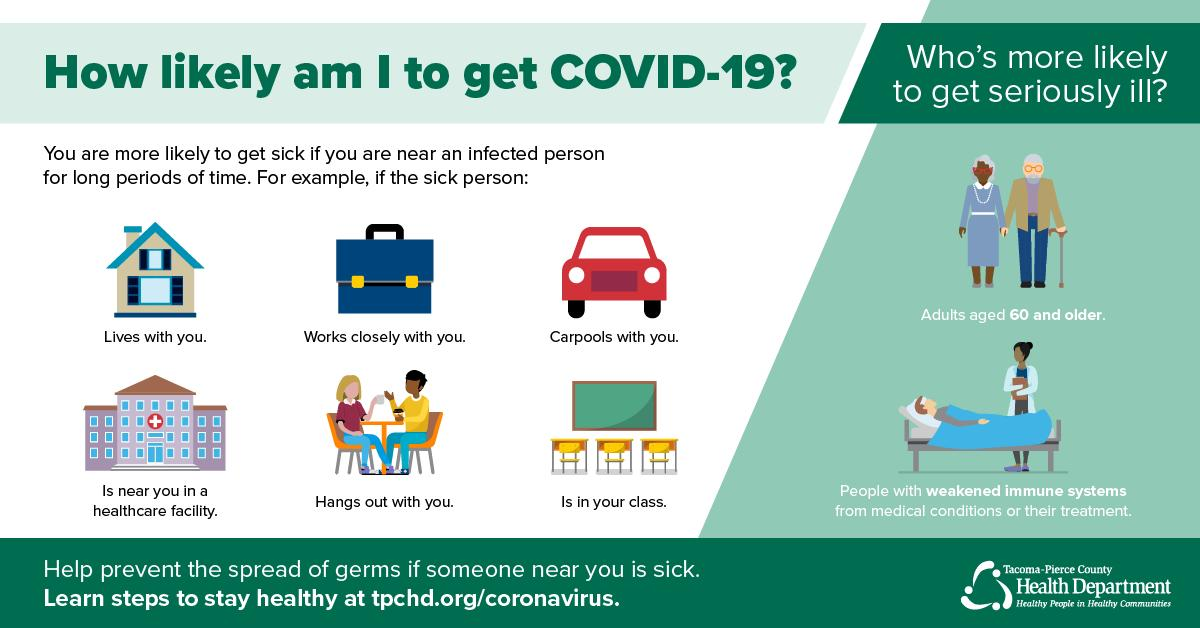Give some essential details in this illustration. Getting sick can result from spending time with an infected person, as evidenced by the fifth way, which involves hanging out with someone who is already infected. It is possible to get sick if one is in close proximity to an infected person, and an additional means of transmission has been identified. Specifically, carpooling with an infected person can also result in infection. 